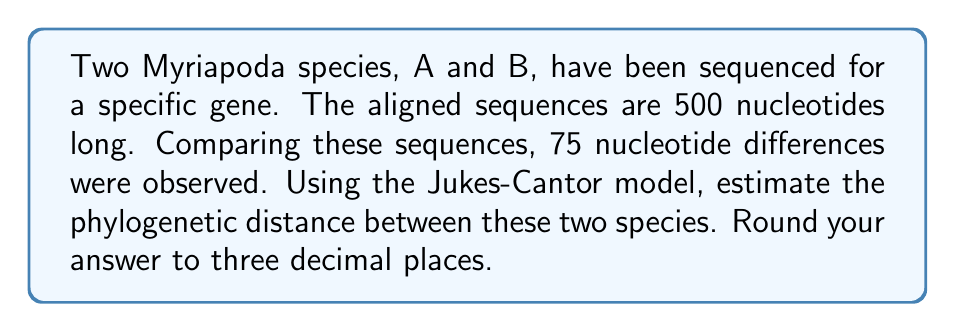Could you help me with this problem? To estimate the phylogenetic distance between two species using the Jukes-Cantor model, we follow these steps:

1. Calculate the proportion of different sites (p):
   $p = \frac{\text{number of differences}}{\text{total sequence length}}$
   $p = \frac{75}{500} = 0.15$

2. Apply the Jukes-Cantor formula:
   $d = -\frac{3}{4} \ln(1 - \frac{4}{3}p)$

   Where:
   $d$ is the estimated evolutionary distance
   $\ln$ is the natural logarithm

3. Substitute the value of $p$ into the formula:
   $d = -\frac{3}{4} \ln(1 - \frac{4}{3} \cdot 0.15)$

4. Simplify:
   $d = -\frac{3}{4} \ln(1 - 0.2)$
   $d = -\frac{3}{4} \ln(0.8)$

5. Calculate:
   $d = -\frac{3}{4} \cdot (-0.223143551)$
   $d = 0.167357663$

6. Round to three decimal places:
   $d \approx 0.167$

This value represents the estimated number of nucleotide substitutions per site between the two Myriapoda species.
Answer: 0.167 